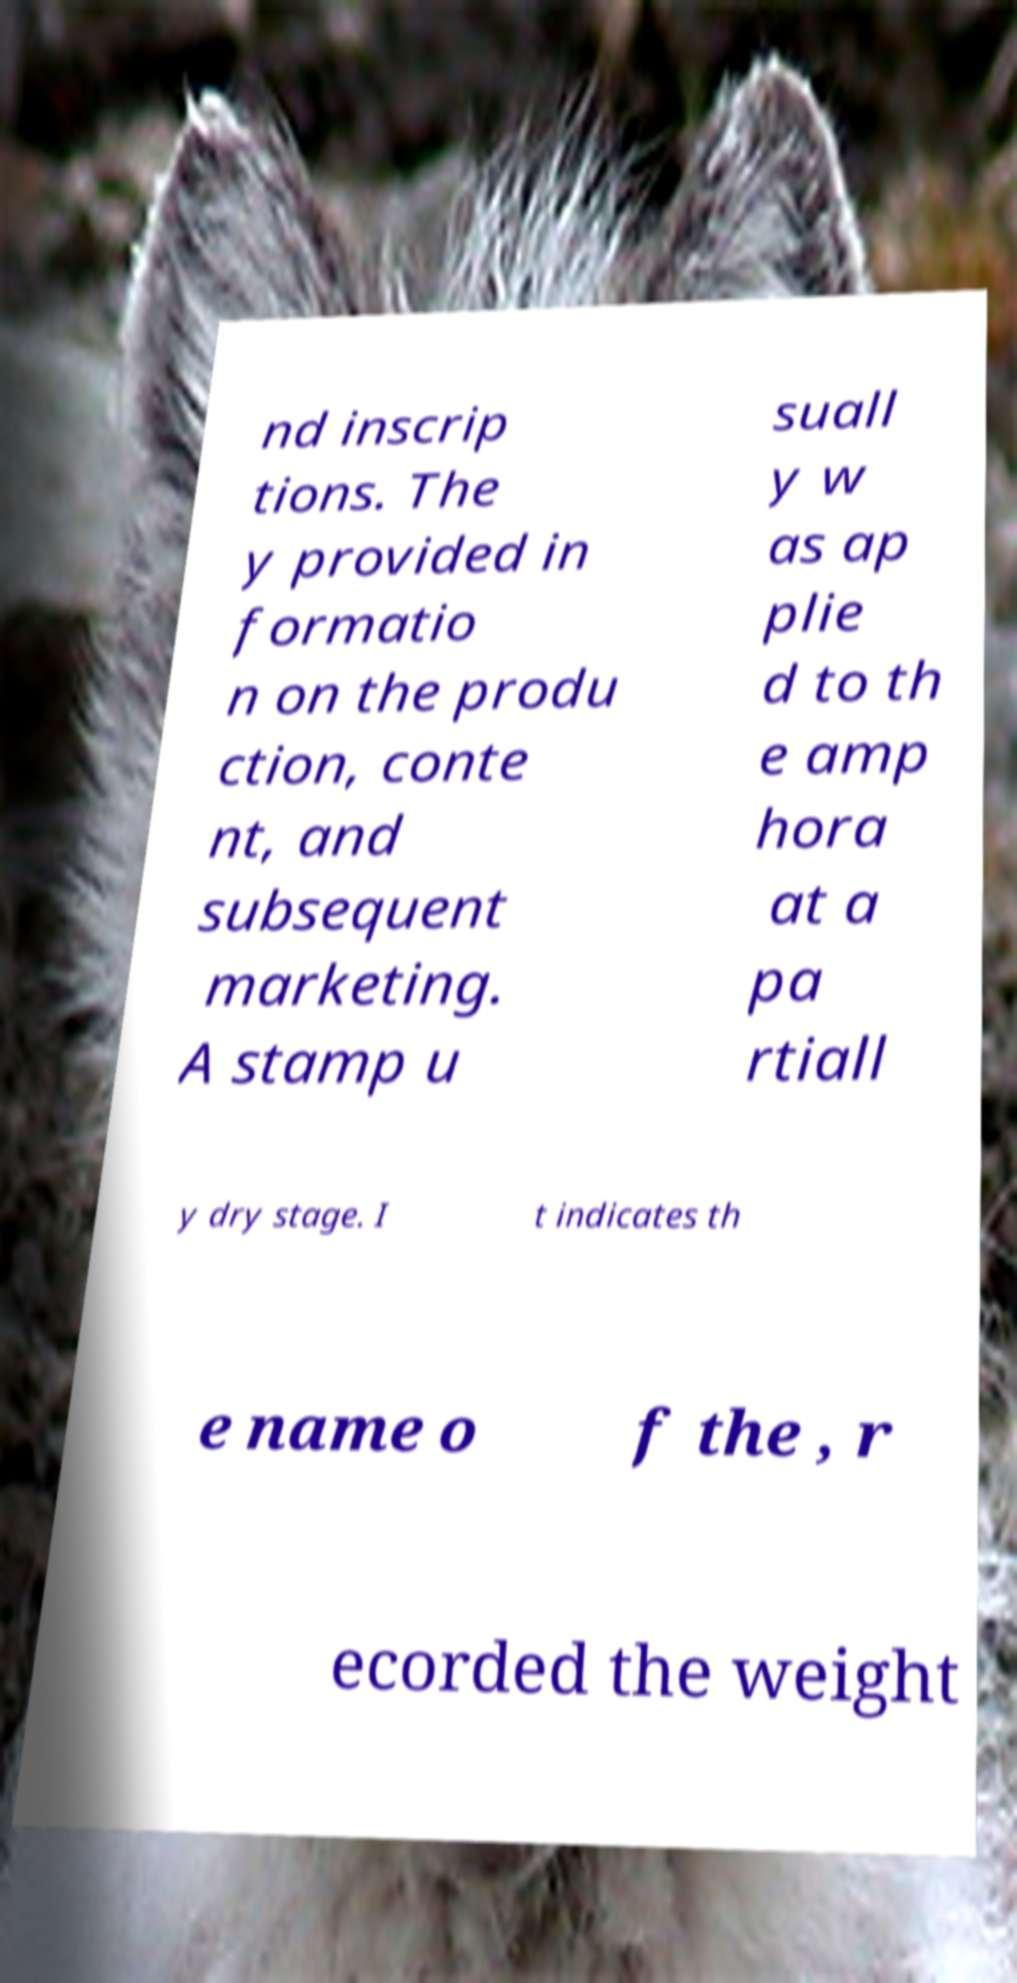Could you extract and type out the text from this image? nd inscrip tions. The y provided in formatio n on the produ ction, conte nt, and subsequent marketing. A stamp u suall y w as ap plie d to th e amp hora at a pa rtiall y dry stage. I t indicates th e name o f the , r ecorded the weight 